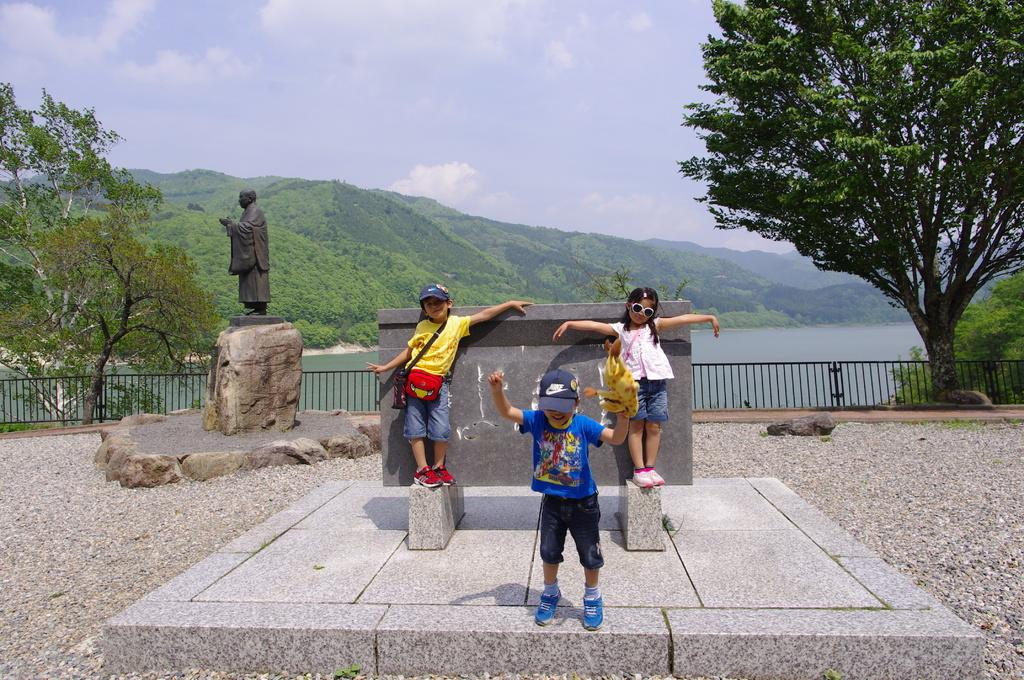What can be seen in the foreground of the image? There are children standing in the front of the image. What is located in the background of the image? There is railing, trees, water, clouds, and a black color sculpture in the background of the image. What is visible in the sky in the image? There are clouds in the sky, and the sky is visible in the image. Are the children's brothers standing next to them in the image? The provided facts do not mention any information about the children's siblings, so it cannot be determined if their brothers are standing next to them in the image. What type of coal is being used to create the sculpture in the image? There is no sculpture made of coal present in the image; the sculpture mentioned in the facts is described as being black in color. 